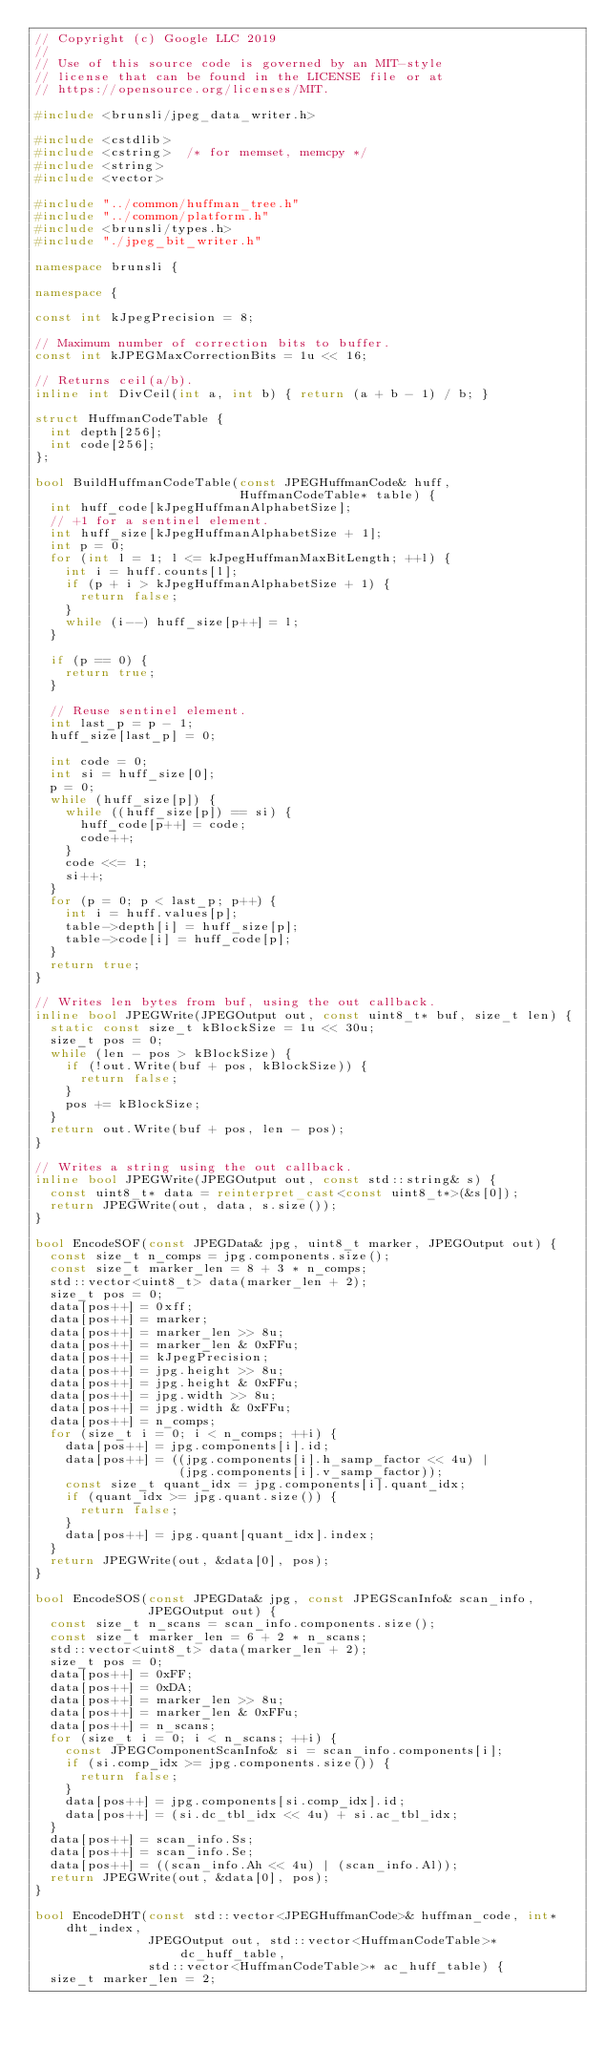<code> <loc_0><loc_0><loc_500><loc_500><_C++_>// Copyright (c) Google LLC 2019
//
// Use of this source code is governed by an MIT-style
// license that can be found in the LICENSE file or at
// https://opensource.org/licenses/MIT.

#include <brunsli/jpeg_data_writer.h>

#include <cstdlib>
#include <cstring>  /* for memset, memcpy */
#include <string>
#include <vector>

#include "../common/huffman_tree.h"
#include "../common/platform.h"
#include <brunsli/types.h>
#include "./jpeg_bit_writer.h"

namespace brunsli {

namespace {

const int kJpegPrecision = 8;

// Maximum number of correction bits to buffer.
const int kJPEGMaxCorrectionBits = 1u << 16;

// Returns ceil(a/b).
inline int DivCeil(int a, int b) { return (a + b - 1) / b; }

struct HuffmanCodeTable {
  int depth[256];
  int code[256];
};

bool BuildHuffmanCodeTable(const JPEGHuffmanCode& huff,
                           HuffmanCodeTable* table) {
  int huff_code[kJpegHuffmanAlphabetSize];
  // +1 for a sentinel element.
  int huff_size[kJpegHuffmanAlphabetSize + 1];
  int p = 0;
  for (int l = 1; l <= kJpegHuffmanMaxBitLength; ++l) {
    int i = huff.counts[l];
    if (p + i > kJpegHuffmanAlphabetSize + 1) {
      return false;
    }
    while (i--) huff_size[p++] = l;
  }

  if (p == 0) {
    return true;
  }

  // Reuse sentinel element.
  int last_p = p - 1;
  huff_size[last_p] = 0;

  int code = 0;
  int si = huff_size[0];
  p = 0;
  while (huff_size[p]) {
    while ((huff_size[p]) == si) {
      huff_code[p++] = code;
      code++;
    }
    code <<= 1;
    si++;
  }
  for (p = 0; p < last_p; p++) {
    int i = huff.values[p];
    table->depth[i] = huff_size[p];
    table->code[i] = huff_code[p];
  }
  return true;
}

// Writes len bytes from buf, using the out callback.
inline bool JPEGWrite(JPEGOutput out, const uint8_t* buf, size_t len) {
  static const size_t kBlockSize = 1u << 30u;
  size_t pos = 0;
  while (len - pos > kBlockSize) {
    if (!out.Write(buf + pos, kBlockSize)) {
      return false;
    }
    pos += kBlockSize;
  }
  return out.Write(buf + pos, len - pos);
}

// Writes a string using the out callback.
inline bool JPEGWrite(JPEGOutput out, const std::string& s) {
  const uint8_t* data = reinterpret_cast<const uint8_t*>(&s[0]);
  return JPEGWrite(out, data, s.size());
}

bool EncodeSOF(const JPEGData& jpg, uint8_t marker, JPEGOutput out) {
  const size_t n_comps = jpg.components.size();
  const size_t marker_len = 8 + 3 * n_comps;
  std::vector<uint8_t> data(marker_len + 2);
  size_t pos = 0;
  data[pos++] = 0xff;
  data[pos++] = marker;
  data[pos++] = marker_len >> 8u;
  data[pos++] = marker_len & 0xFFu;
  data[pos++] = kJpegPrecision;
  data[pos++] = jpg.height >> 8u;
  data[pos++] = jpg.height & 0xFFu;
  data[pos++] = jpg.width >> 8u;
  data[pos++] = jpg.width & 0xFFu;
  data[pos++] = n_comps;
  for (size_t i = 0; i < n_comps; ++i) {
    data[pos++] = jpg.components[i].id;
    data[pos++] = ((jpg.components[i].h_samp_factor << 4u) |
                   (jpg.components[i].v_samp_factor));
    const size_t quant_idx = jpg.components[i].quant_idx;
    if (quant_idx >= jpg.quant.size()) {
      return false;
    }
    data[pos++] = jpg.quant[quant_idx].index;
  }
  return JPEGWrite(out, &data[0], pos);
}

bool EncodeSOS(const JPEGData& jpg, const JPEGScanInfo& scan_info,
               JPEGOutput out) {
  const size_t n_scans = scan_info.components.size();
  const size_t marker_len = 6 + 2 * n_scans;
  std::vector<uint8_t> data(marker_len + 2);
  size_t pos = 0;
  data[pos++] = 0xFF;
  data[pos++] = 0xDA;
  data[pos++] = marker_len >> 8u;
  data[pos++] = marker_len & 0xFFu;
  data[pos++] = n_scans;
  for (size_t i = 0; i < n_scans; ++i) {
    const JPEGComponentScanInfo& si = scan_info.components[i];
    if (si.comp_idx >= jpg.components.size()) {
      return false;
    }
    data[pos++] = jpg.components[si.comp_idx].id;
    data[pos++] = (si.dc_tbl_idx << 4u) + si.ac_tbl_idx;
  }
  data[pos++] = scan_info.Ss;
  data[pos++] = scan_info.Se;
  data[pos++] = ((scan_info.Ah << 4u) | (scan_info.Al));
  return JPEGWrite(out, &data[0], pos);
}

bool EncodeDHT(const std::vector<JPEGHuffmanCode>& huffman_code, int* dht_index,
               JPEGOutput out, std::vector<HuffmanCodeTable>* dc_huff_table,
               std::vector<HuffmanCodeTable>* ac_huff_table) {
  size_t marker_len = 2;</code> 